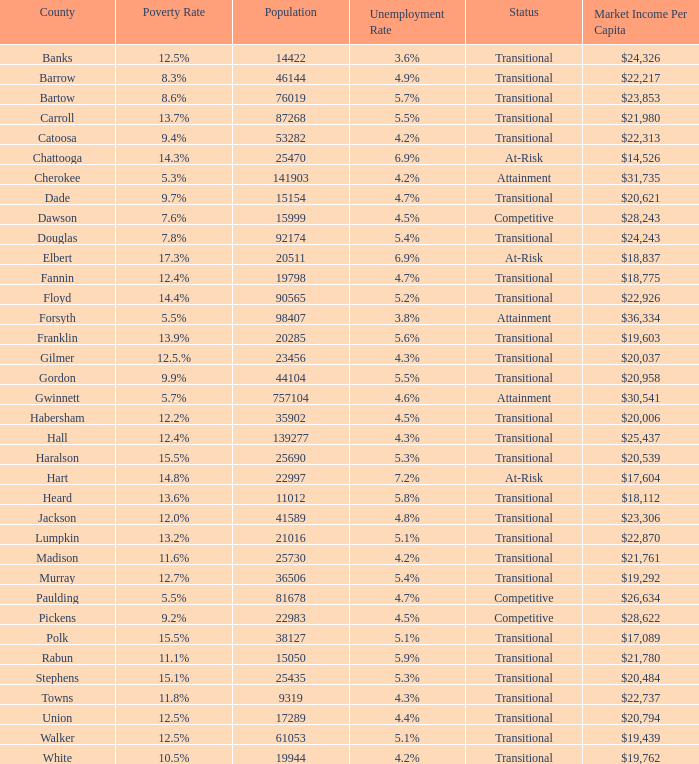What is the market income per capita of the county with the 9.4% poverty rate? $22,313. 